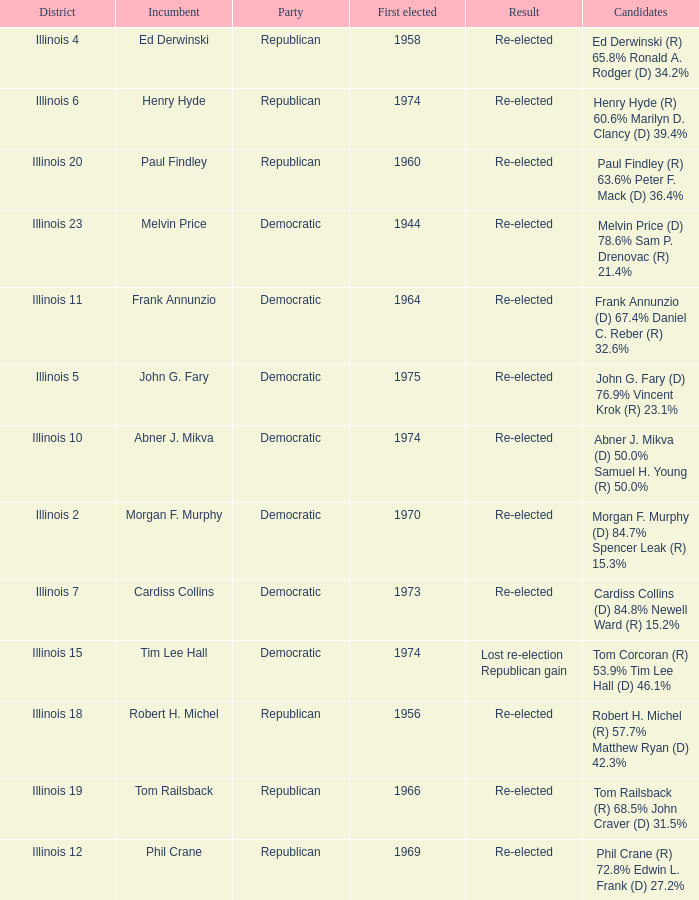Name the number of first elected for phil crane 1.0. 